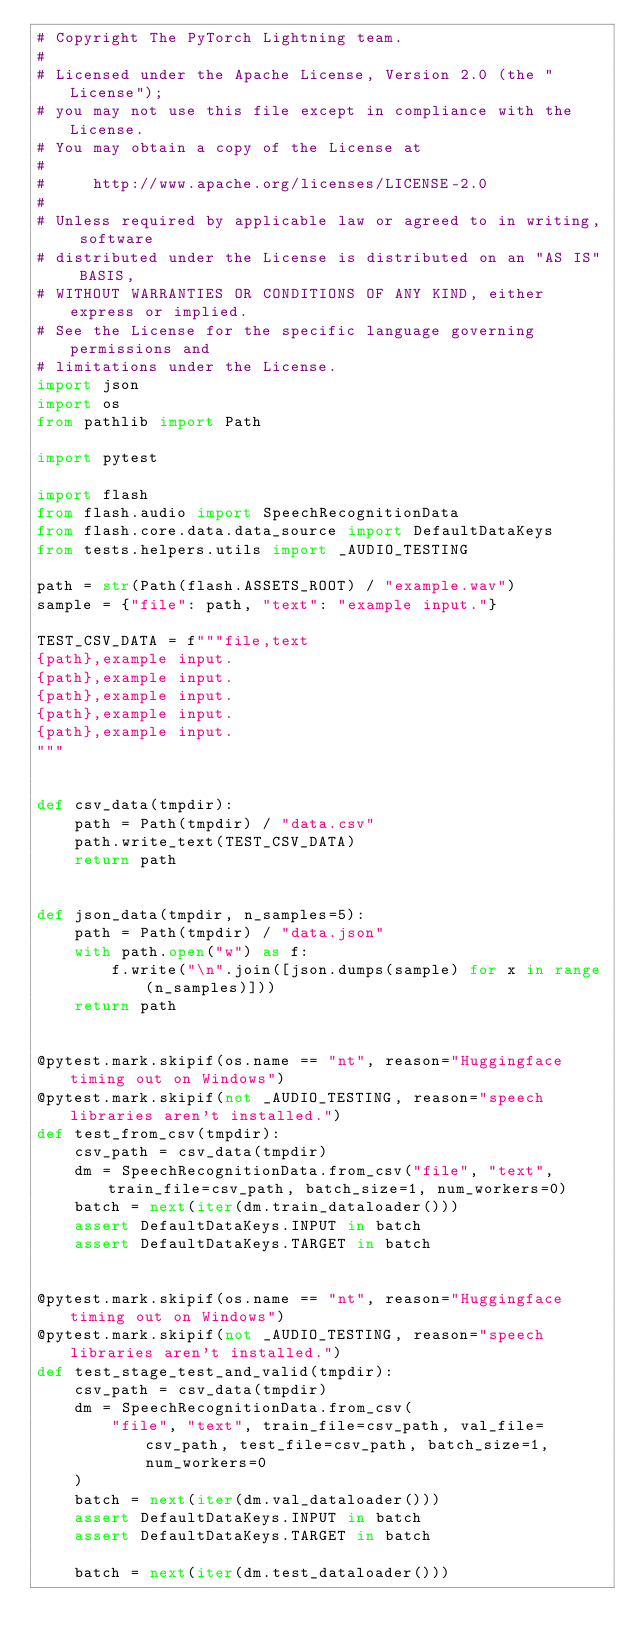Convert code to text. <code><loc_0><loc_0><loc_500><loc_500><_Python_># Copyright The PyTorch Lightning team.
#
# Licensed under the Apache License, Version 2.0 (the "License");
# you may not use this file except in compliance with the License.
# You may obtain a copy of the License at
#
#     http://www.apache.org/licenses/LICENSE-2.0
#
# Unless required by applicable law or agreed to in writing, software
# distributed under the License is distributed on an "AS IS" BASIS,
# WITHOUT WARRANTIES OR CONDITIONS OF ANY KIND, either express or implied.
# See the License for the specific language governing permissions and
# limitations under the License.
import json
import os
from pathlib import Path

import pytest

import flash
from flash.audio import SpeechRecognitionData
from flash.core.data.data_source import DefaultDataKeys
from tests.helpers.utils import _AUDIO_TESTING

path = str(Path(flash.ASSETS_ROOT) / "example.wav")
sample = {"file": path, "text": "example input."}

TEST_CSV_DATA = f"""file,text
{path},example input.
{path},example input.
{path},example input.
{path},example input.
{path},example input.
"""


def csv_data(tmpdir):
    path = Path(tmpdir) / "data.csv"
    path.write_text(TEST_CSV_DATA)
    return path


def json_data(tmpdir, n_samples=5):
    path = Path(tmpdir) / "data.json"
    with path.open("w") as f:
        f.write("\n".join([json.dumps(sample) for x in range(n_samples)]))
    return path


@pytest.mark.skipif(os.name == "nt", reason="Huggingface timing out on Windows")
@pytest.mark.skipif(not _AUDIO_TESTING, reason="speech libraries aren't installed.")
def test_from_csv(tmpdir):
    csv_path = csv_data(tmpdir)
    dm = SpeechRecognitionData.from_csv("file", "text", train_file=csv_path, batch_size=1, num_workers=0)
    batch = next(iter(dm.train_dataloader()))
    assert DefaultDataKeys.INPUT in batch
    assert DefaultDataKeys.TARGET in batch


@pytest.mark.skipif(os.name == "nt", reason="Huggingface timing out on Windows")
@pytest.mark.skipif(not _AUDIO_TESTING, reason="speech libraries aren't installed.")
def test_stage_test_and_valid(tmpdir):
    csv_path = csv_data(tmpdir)
    dm = SpeechRecognitionData.from_csv(
        "file", "text", train_file=csv_path, val_file=csv_path, test_file=csv_path, batch_size=1, num_workers=0
    )
    batch = next(iter(dm.val_dataloader()))
    assert DefaultDataKeys.INPUT in batch
    assert DefaultDataKeys.TARGET in batch

    batch = next(iter(dm.test_dataloader()))</code> 